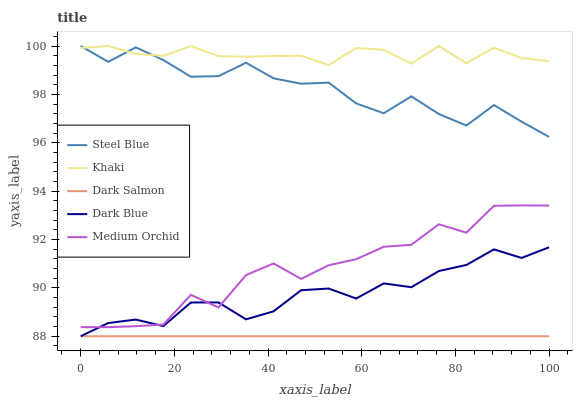Does Dark Salmon have the minimum area under the curve?
Answer yes or no. Yes. Does Khaki have the maximum area under the curve?
Answer yes or no. Yes. Does Medium Orchid have the minimum area under the curve?
Answer yes or no. No. Does Medium Orchid have the maximum area under the curve?
Answer yes or no. No. Is Dark Salmon the smoothest?
Answer yes or no. Yes. Is Medium Orchid the roughest?
Answer yes or no. Yes. Is Khaki the smoothest?
Answer yes or no. No. Is Khaki the roughest?
Answer yes or no. No. Does Dark Blue have the lowest value?
Answer yes or no. Yes. Does Medium Orchid have the lowest value?
Answer yes or no. No. Does Steel Blue have the highest value?
Answer yes or no. Yes. Does Medium Orchid have the highest value?
Answer yes or no. No. Is Medium Orchid less than Steel Blue?
Answer yes or no. Yes. Is Steel Blue greater than Dark Blue?
Answer yes or no. Yes. Does Dark Blue intersect Dark Salmon?
Answer yes or no. Yes. Is Dark Blue less than Dark Salmon?
Answer yes or no. No. Is Dark Blue greater than Dark Salmon?
Answer yes or no. No. Does Medium Orchid intersect Steel Blue?
Answer yes or no. No. 